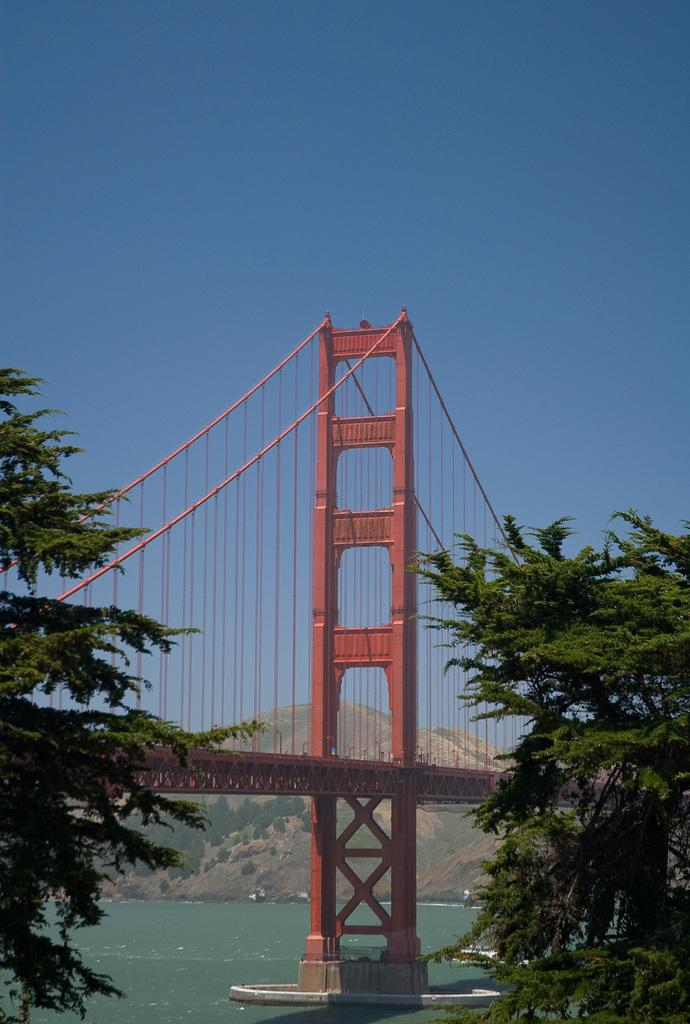What type of vegetation can be seen on the left side of the image? There are trees on the left side of the image. What type of vegetation can be seen on the right side of the image? There are trees on the right side of the image. What structure can be seen in the background of the image? There is a bridge in the background of the image. What type of vehicle can be seen on the water in the background of the image? There is a boat on the water in the background of the image. What type of terrain can be seen in the background of the image? There are trees on a mountain in the background of the image. What is visible in the sky in the background of the image? The sky is visible in the background of the image. What type of ink can be seen dripping from the tree in the image? There is no ink present in the image; it features trees, a bridge, a boat, and a mountain. Can you describe the bear that is walking across the bridge in the image? There is no bear present in the image; it features trees, a bridge, a boat, and a mountain. 